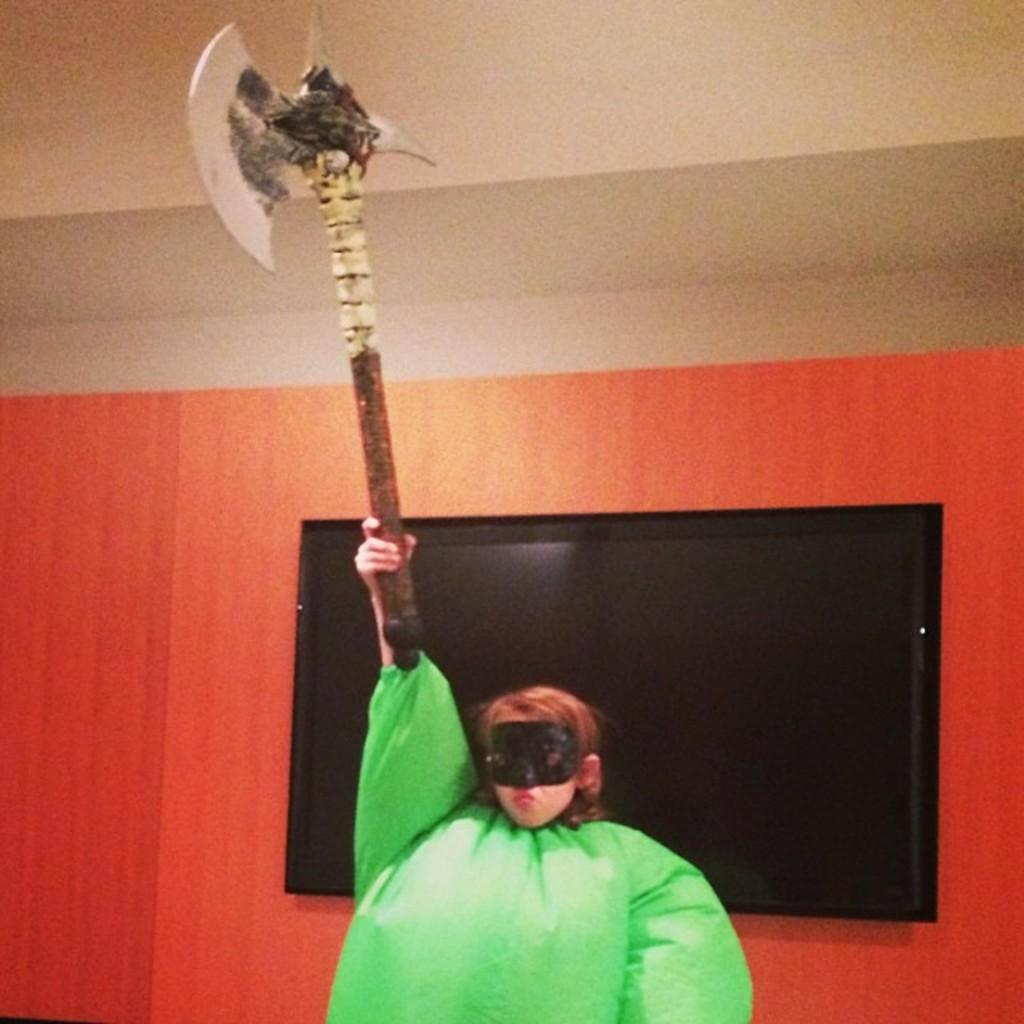What is the person in the image holding? The person is holding a weapon in the image. What is the person wearing? The person is wearing a green dress. What can be seen in the background of the image? There is a screen in the background of the image. What colors are present on the wall in the image? The wall has a cream and orange color. What type of sack is being used to carry the weapon in the image? There is no sack present in the image; the person is holding the weapon directly. 